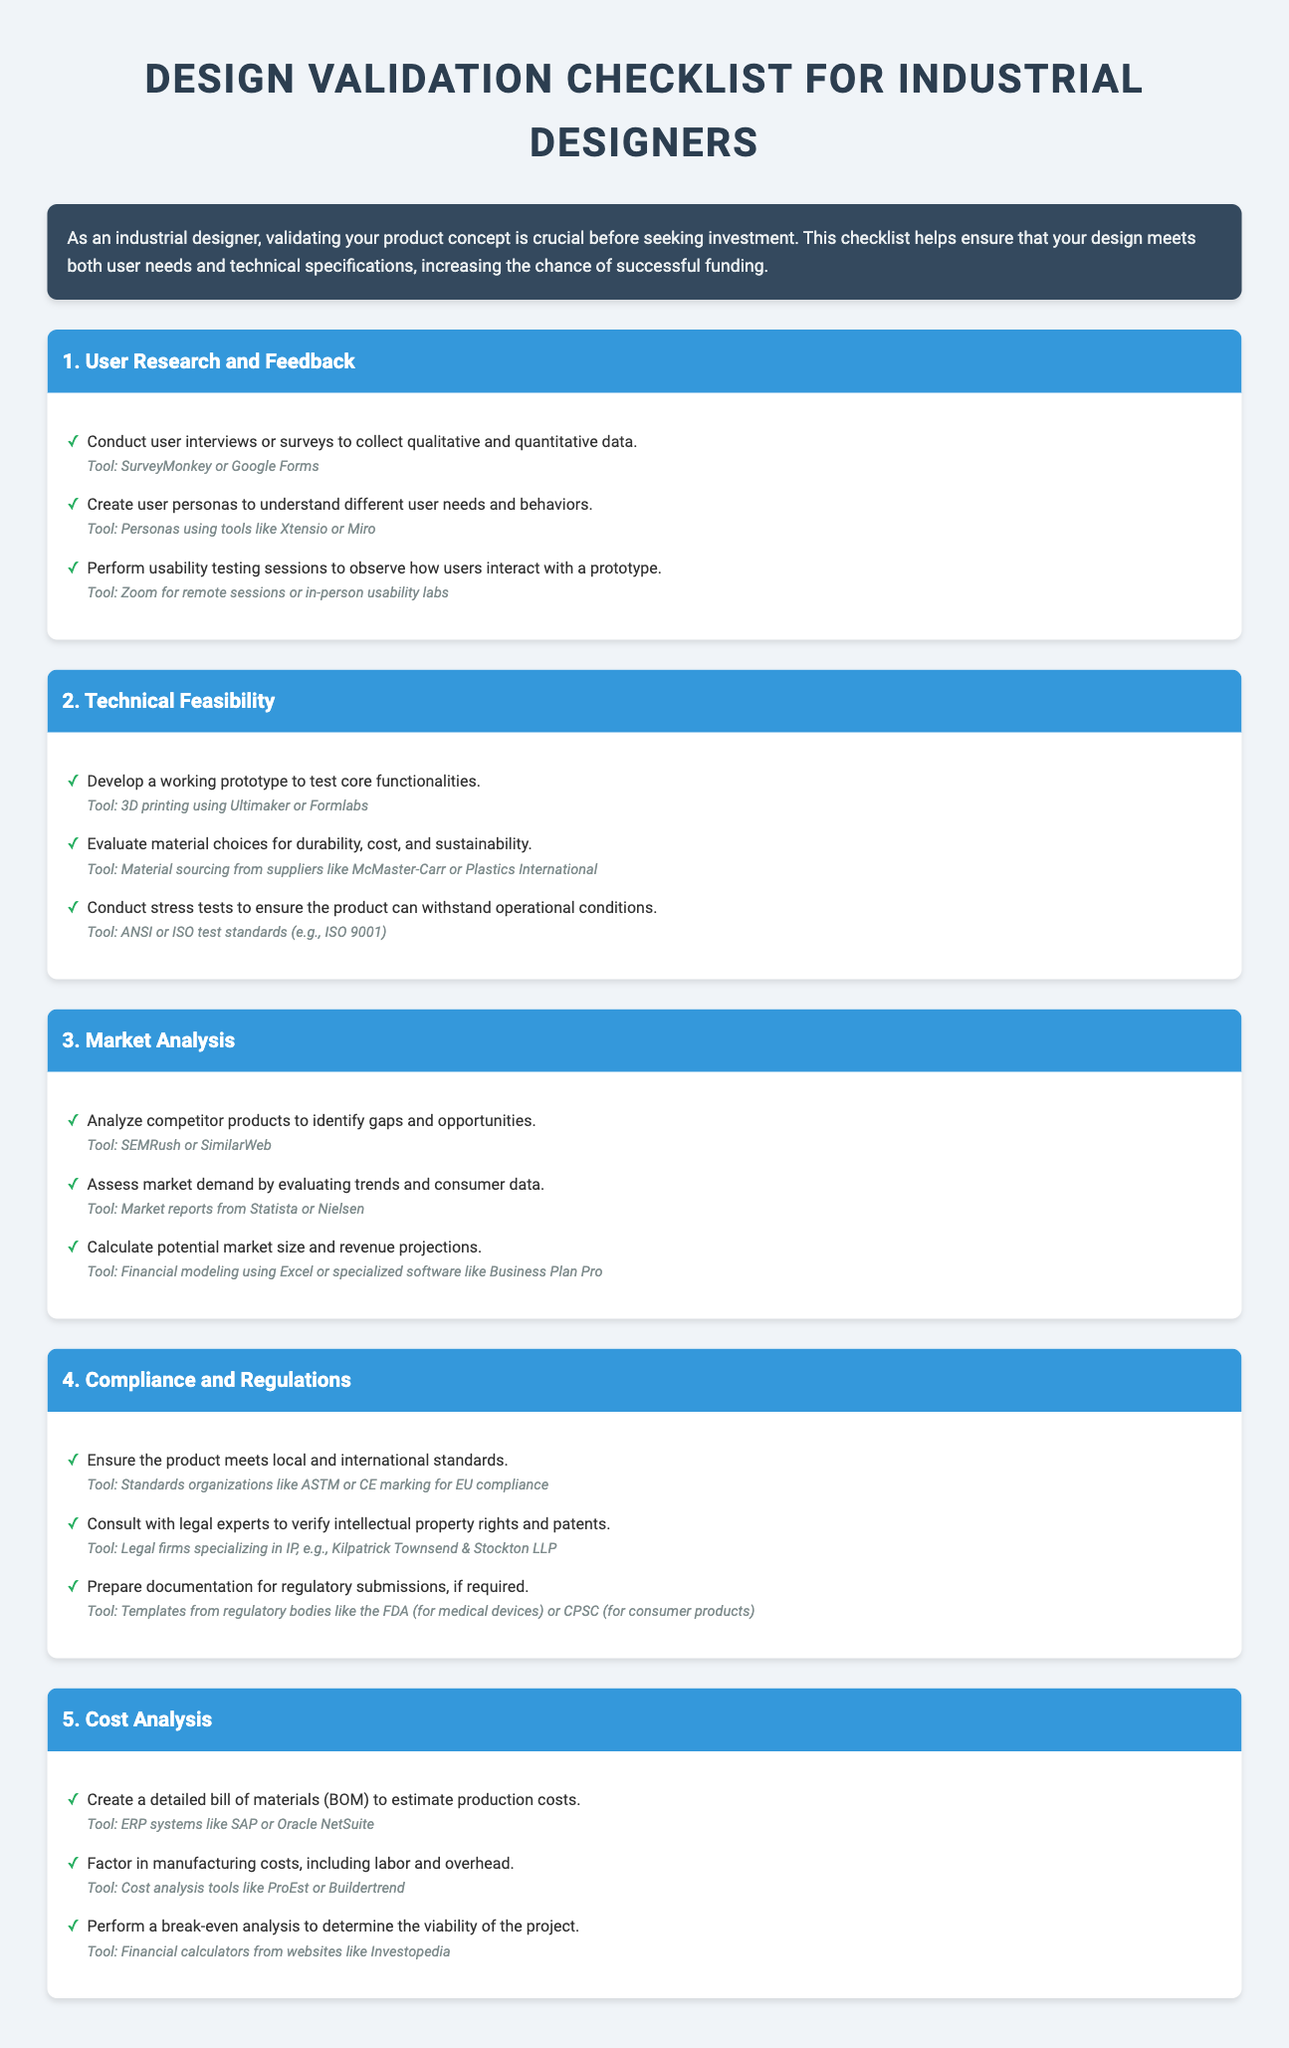What is the title of the document? The title of the document is the main heading presented at the top of the document.
Answer: Design Validation Checklist for Industrial Designers What is one tool suggested for conducting user interviews? The document lists a specific tool that can be used for collecting qualitative and quantitative data during user research.
Answer: SurveyMonkey or Google Forms How many sections are in the checklist? The number of sections can be counted from the headings in the document.
Answer: 5 What is the purpose of the Design Validation Checklist? The main purpose is provided in the introduction and can be summarized in one phrase.
Answer: To validate product concepts Which tool is recommended for creating a working prototype? The specific tool recommended for developing and testing the prototype is mentioned in the technical feasibility section.
Answer: 3D printing using Ultimaker or Formlabs What type of analysis is performed to calculate potential market size? The document specifies a particular type of analysis that is used in the market analysis section for this purpose.
Answer: Financial modeling Name one organization to consult for compliance with international standards. There is a suggestion for an organization in the compliance and regulations section that provides guidance.
Answer: ASTM What is a tool for performing a break-even analysis? The document states a resource that can assist in this financial analysis.
Answer: Financial calculators from websites like Investopedia 